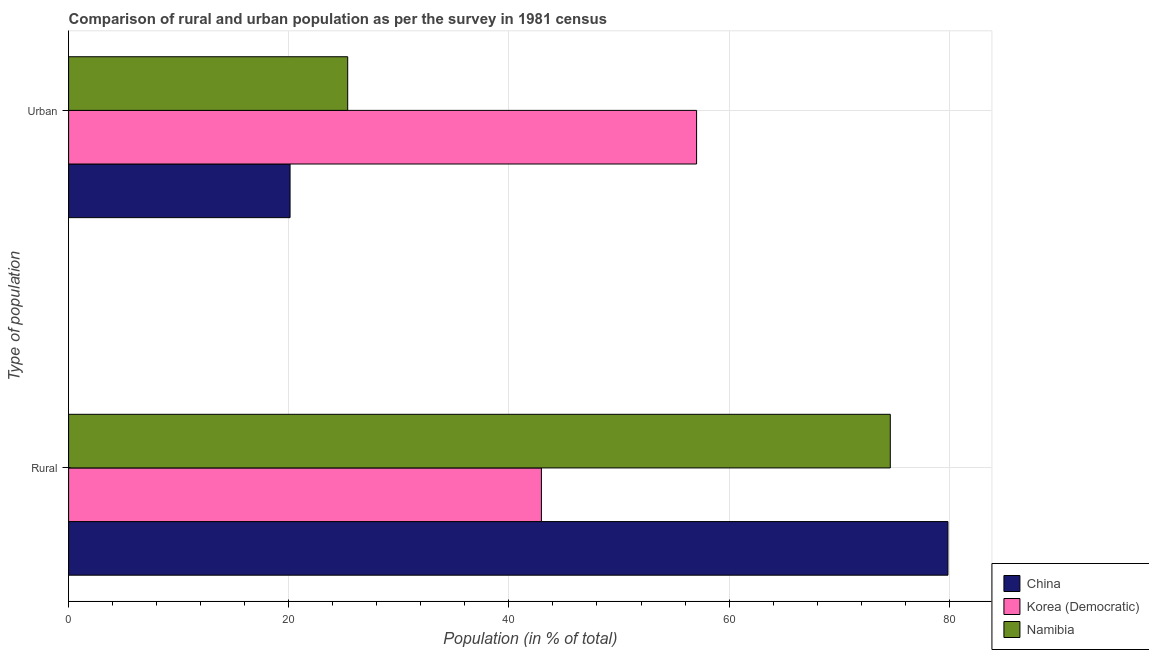How many groups of bars are there?
Provide a short and direct response. 2. Are the number of bars on each tick of the Y-axis equal?
Offer a terse response. Yes. What is the label of the 2nd group of bars from the top?
Make the answer very short. Rural. What is the rural population in Korea (Democratic)?
Provide a succinct answer. 42.95. Across all countries, what is the maximum rural population?
Ensure brevity in your answer.  79.88. Across all countries, what is the minimum urban population?
Make the answer very short. 20.12. In which country was the rural population maximum?
Make the answer very short. China. In which country was the urban population minimum?
Give a very brief answer. China. What is the total rural population in the graph?
Make the answer very short. 197.48. What is the difference between the urban population in Namibia and that in China?
Give a very brief answer. 5.24. What is the difference between the urban population in Korea (Democratic) and the rural population in Namibia?
Offer a very short reply. -17.6. What is the average urban population per country?
Your answer should be compact. 34.17. What is the difference between the urban population and rural population in China?
Make the answer very short. -59.76. What is the ratio of the rural population in Korea (Democratic) to that in Namibia?
Provide a succinct answer. 0.58. In how many countries, is the rural population greater than the average rural population taken over all countries?
Give a very brief answer. 2. What does the 3rd bar from the top in Urban represents?
Ensure brevity in your answer.  China. What does the 3rd bar from the bottom in Rural represents?
Your response must be concise. Namibia. How many bars are there?
Give a very brief answer. 6. Are all the bars in the graph horizontal?
Provide a succinct answer. Yes. What is the difference between two consecutive major ticks on the X-axis?
Provide a succinct answer. 20. Are the values on the major ticks of X-axis written in scientific E-notation?
Ensure brevity in your answer.  No. Does the graph contain grids?
Your answer should be very brief. Yes. How many legend labels are there?
Your answer should be compact. 3. What is the title of the graph?
Provide a succinct answer. Comparison of rural and urban population as per the survey in 1981 census. What is the label or title of the X-axis?
Your answer should be compact. Population (in % of total). What is the label or title of the Y-axis?
Keep it short and to the point. Type of population. What is the Population (in % of total) in China in Rural?
Give a very brief answer. 79.88. What is the Population (in % of total) of Korea (Democratic) in Rural?
Offer a very short reply. 42.95. What is the Population (in % of total) in Namibia in Rural?
Offer a very short reply. 74.64. What is the Population (in % of total) in China in Urban?
Provide a succinct answer. 20.12. What is the Population (in % of total) of Korea (Democratic) in Urban?
Provide a short and direct response. 57.05. What is the Population (in % of total) in Namibia in Urban?
Provide a short and direct response. 25.36. Across all Type of population, what is the maximum Population (in % of total) of China?
Offer a terse response. 79.88. Across all Type of population, what is the maximum Population (in % of total) of Korea (Democratic)?
Make the answer very short. 57.05. Across all Type of population, what is the maximum Population (in % of total) of Namibia?
Provide a succinct answer. 74.64. Across all Type of population, what is the minimum Population (in % of total) in China?
Your answer should be compact. 20.12. Across all Type of population, what is the minimum Population (in % of total) of Korea (Democratic)?
Make the answer very short. 42.95. Across all Type of population, what is the minimum Population (in % of total) in Namibia?
Make the answer very short. 25.36. What is the total Population (in % of total) in Namibia in the graph?
Keep it short and to the point. 100. What is the difference between the Population (in % of total) in China in Rural and that in Urban?
Your answer should be compact. 59.76. What is the difference between the Population (in % of total) of Korea (Democratic) in Rural and that in Urban?
Make the answer very short. -14.1. What is the difference between the Population (in % of total) of Namibia in Rural and that in Urban?
Ensure brevity in your answer.  49.29. What is the difference between the Population (in % of total) in China in Rural and the Population (in % of total) in Korea (Democratic) in Urban?
Your response must be concise. 22.83. What is the difference between the Population (in % of total) in China in Rural and the Population (in % of total) in Namibia in Urban?
Ensure brevity in your answer.  54.53. What is the difference between the Population (in % of total) in Korea (Democratic) in Rural and the Population (in % of total) in Namibia in Urban?
Make the answer very short. 17.6. What is the average Population (in % of total) of Korea (Democratic) per Type of population?
Provide a short and direct response. 50. What is the average Population (in % of total) of Namibia per Type of population?
Your answer should be compact. 50. What is the difference between the Population (in % of total) of China and Population (in % of total) of Korea (Democratic) in Rural?
Your answer should be compact. 36.93. What is the difference between the Population (in % of total) of China and Population (in % of total) of Namibia in Rural?
Offer a terse response. 5.24. What is the difference between the Population (in % of total) in Korea (Democratic) and Population (in % of total) in Namibia in Rural?
Give a very brief answer. -31.69. What is the difference between the Population (in % of total) in China and Population (in % of total) in Korea (Democratic) in Urban?
Ensure brevity in your answer.  -36.93. What is the difference between the Population (in % of total) in China and Population (in % of total) in Namibia in Urban?
Provide a short and direct response. -5.24. What is the difference between the Population (in % of total) in Korea (Democratic) and Population (in % of total) in Namibia in Urban?
Offer a terse response. 31.69. What is the ratio of the Population (in % of total) in China in Rural to that in Urban?
Provide a short and direct response. 3.97. What is the ratio of the Population (in % of total) of Korea (Democratic) in Rural to that in Urban?
Ensure brevity in your answer.  0.75. What is the ratio of the Population (in % of total) in Namibia in Rural to that in Urban?
Give a very brief answer. 2.94. What is the difference between the highest and the second highest Population (in % of total) of China?
Keep it short and to the point. 59.76. What is the difference between the highest and the second highest Population (in % of total) in Korea (Democratic)?
Provide a succinct answer. 14.1. What is the difference between the highest and the second highest Population (in % of total) in Namibia?
Your response must be concise. 49.29. What is the difference between the highest and the lowest Population (in % of total) in China?
Ensure brevity in your answer.  59.76. What is the difference between the highest and the lowest Population (in % of total) in Korea (Democratic)?
Your answer should be compact. 14.1. What is the difference between the highest and the lowest Population (in % of total) of Namibia?
Give a very brief answer. 49.29. 